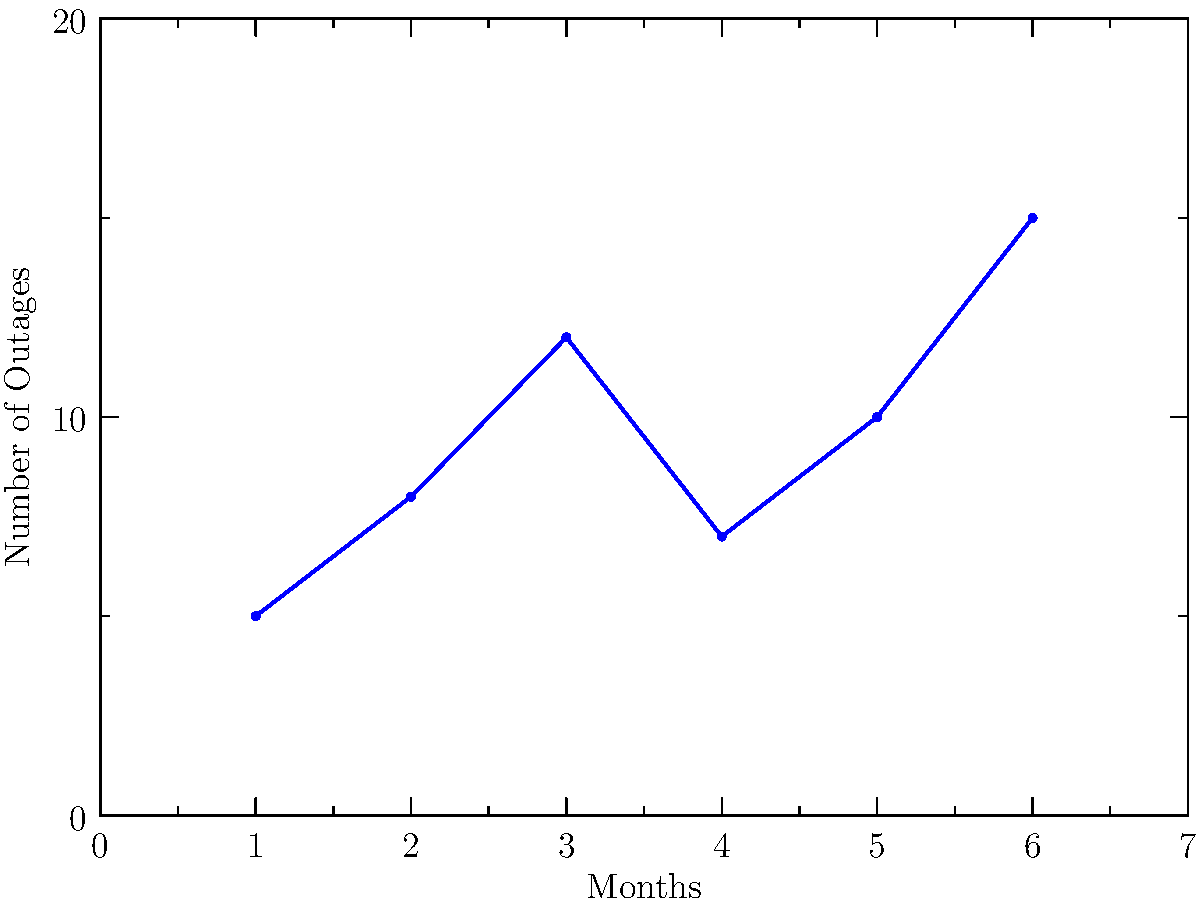Based on the time series graph showing power outages over six months, which month experienced the highest number of outages, and what was the primary cause attributed to this spike? To answer this question, we need to analyze the graph step-by-step:

1. Examine the y-axis, which represents the "Number of Outages".
2. Scan the blue line graph to identify the highest peak.
3. The highest peak occurs at month 6, with approximately 15 outages.
4. Look for any labels or annotations near this peak.
5. We can see a label "Cyber Attack" near the month 6 data point.
6. This label suggests that the primary cause of the spike in outages was a cyber attack.

The graph shows a clear increase in outages over the six-month period, with the most significant spike occurring in the last month. As the CIO of a power utility company, this information is crucial for understanding and mitigating risks to the infrastructure. The attribution of the largest spike to a cyber attack highlights the importance of robust cybersecurity measures in protecting critical power infrastructure.
Answer: Month 6; Cyber Attack 